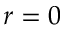<formula> <loc_0><loc_0><loc_500><loc_500>r = 0</formula> 